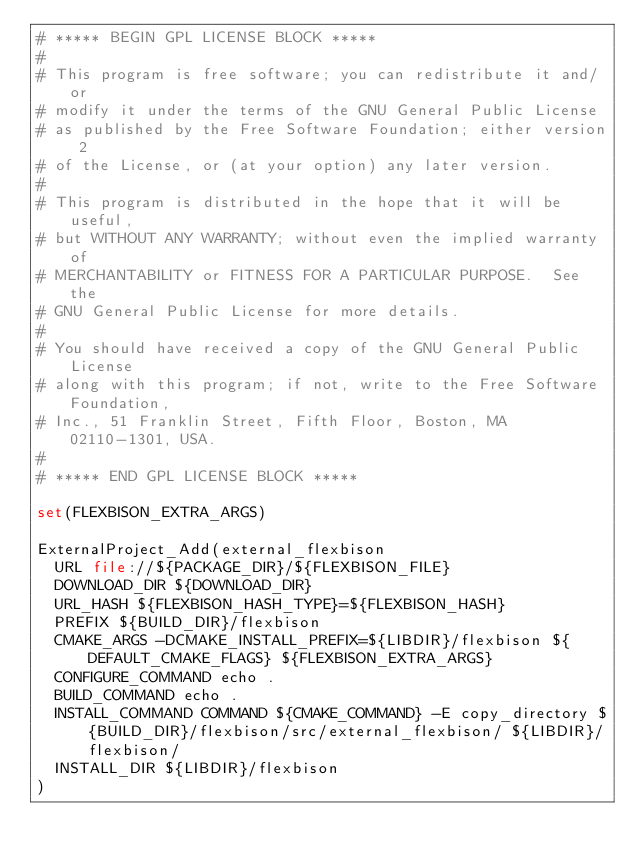<code> <loc_0><loc_0><loc_500><loc_500><_CMake_># ***** BEGIN GPL LICENSE BLOCK *****
#
# This program is free software; you can redistribute it and/or
# modify it under the terms of the GNU General Public License
# as published by the Free Software Foundation; either version 2
# of the License, or (at your option) any later version.
#
# This program is distributed in the hope that it will be useful,
# but WITHOUT ANY WARRANTY; without even the implied warranty of
# MERCHANTABILITY or FITNESS FOR A PARTICULAR PURPOSE.  See the
# GNU General Public License for more details.
#
# You should have received a copy of the GNU General Public License
# along with this program; if not, write to the Free Software Foundation,
# Inc., 51 Franklin Street, Fifth Floor, Boston, MA 02110-1301, USA.
#
# ***** END GPL LICENSE BLOCK *****

set(FLEXBISON_EXTRA_ARGS)

ExternalProject_Add(external_flexbison
  URL file://${PACKAGE_DIR}/${FLEXBISON_FILE}
  DOWNLOAD_DIR ${DOWNLOAD_DIR}
  URL_HASH ${FLEXBISON_HASH_TYPE}=${FLEXBISON_HASH}
  PREFIX ${BUILD_DIR}/flexbison
  CMAKE_ARGS -DCMAKE_INSTALL_PREFIX=${LIBDIR}/flexbison ${DEFAULT_CMAKE_FLAGS} ${FLEXBISON_EXTRA_ARGS}
  CONFIGURE_COMMAND echo .
  BUILD_COMMAND echo .
  INSTALL_COMMAND COMMAND ${CMAKE_COMMAND} -E copy_directory ${BUILD_DIR}/flexbison/src/external_flexbison/ ${LIBDIR}/flexbison/
  INSTALL_DIR ${LIBDIR}/flexbison
)
</code> 